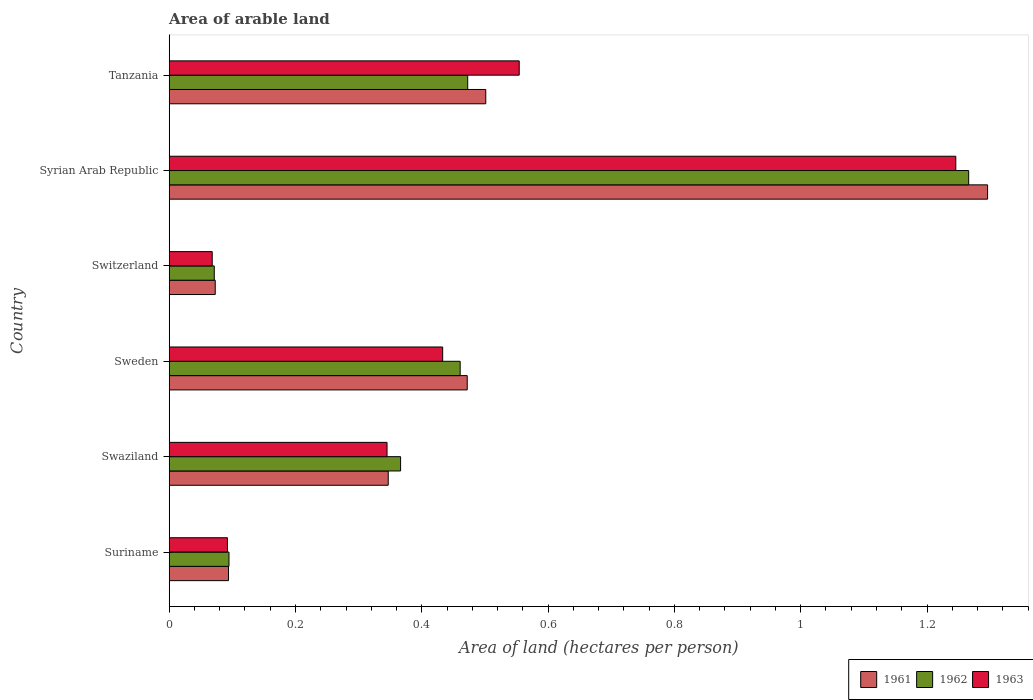How many different coloured bars are there?
Your response must be concise. 3. Are the number of bars per tick equal to the number of legend labels?
Ensure brevity in your answer.  Yes. How many bars are there on the 1st tick from the top?
Give a very brief answer. 3. What is the label of the 1st group of bars from the top?
Offer a terse response. Tanzania. In how many cases, is the number of bars for a given country not equal to the number of legend labels?
Keep it short and to the point. 0. What is the total arable land in 1961 in Syrian Arab Republic?
Offer a terse response. 1.3. Across all countries, what is the maximum total arable land in 1962?
Offer a very short reply. 1.27. Across all countries, what is the minimum total arable land in 1961?
Offer a very short reply. 0.07. In which country was the total arable land in 1962 maximum?
Your answer should be compact. Syrian Arab Republic. In which country was the total arable land in 1963 minimum?
Provide a short and direct response. Switzerland. What is the total total arable land in 1962 in the graph?
Offer a terse response. 2.73. What is the difference between the total arable land in 1962 in Swaziland and that in Tanzania?
Your answer should be compact. -0.11. What is the difference between the total arable land in 1961 in Syrian Arab Republic and the total arable land in 1963 in Tanzania?
Provide a succinct answer. 0.74. What is the average total arable land in 1963 per country?
Your response must be concise. 0.46. What is the difference between the total arable land in 1962 and total arable land in 1961 in Sweden?
Offer a terse response. -0.01. What is the ratio of the total arable land in 1962 in Swaziland to that in Switzerland?
Provide a short and direct response. 5.14. What is the difference between the highest and the second highest total arable land in 1963?
Offer a very short reply. 0.69. What is the difference between the highest and the lowest total arable land in 1962?
Offer a terse response. 1.19. In how many countries, is the total arable land in 1961 greater than the average total arable land in 1961 taken over all countries?
Your response must be concise. 3. What does the 3rd bar from the top in Swaziland represents?
Your response must be concise. 1961. Is it the case that in every country, the sum of the total arable land in 1961 and total arable land in 1962 is greater than the total arable land in 1963?
Keep it short and to the point. Yes. How many bars are there?
Make the answer very short. 18. Are all the bars in the graph horizontal?
Provide a short and direct response. Yes. How many countries are there in the graph?
Ensure brevity in your answer.  6. Are the values on the major ticks of X-axis written in scientific E-notation?
Your answer should be very brief. No. Does the graph contain any zero values?
Your response must be concise. No. How many legend labels are there?
Give a very brief answer. 3. How are the legend labels stacked?
Provide a succinct answer. Horizontal. What is the title of the graph?
Ensure brevity in your answer.  Area of arable land. Does "2003" appear as one of the legend labels in the graph?
Make the answer very short. No. What is the label or title of the X-axis?
Your answer should be very brief. Area of land (hectares per person). What is the Area of land (hectares per person) in 1961 in Suriname?
Make the answer very short. 0.09. What is the Area of land (hectares per person) of 1962 in Suriname?
Your response must be concise. 0.09. What is the Area of land (hectares per person) in 1963 in Suriname?
Provide a short and direct response. 0.09. What is the Area of land (hectares per person) of 1961 in Swaziland?
Provide a succinct answer. 0.35. What is the Area of land (hectares per person) in 1962 in Swaziland?
Your response must be concise. 0.37. What is the Area of land (hectares per person) in 1963 in Swaziland?
Your answer should be very brief. 0.34. What is the Area of land (hectares per person) in 1961 in Sweden?
Provide a short and direct response. 0.47. What is the Area of land (hectares per person) in 1962 in Sweden?
Offer a terse response. 0.46. What is the Area of land (hectares per person) in 1963 in Sweden?
Ensure brevity in your answer.  0.43. What is the Area of land (hectares per person) of 1961 in Switzerland?
Make the answer very short. 0.07. What is the Area of land (hectares per person) of 1962 in Switzerland?
Your answer should be compact. 0.07. What is the Area of land (hectares per person) in 1963 in Switzerland?
Your response must be concise. 0.07. What is the Area of land (hectares per person) of 1961 in Syrian Arab Republic?
Your response must be concise. 1.3. What is the Area of land (hectares per person) of 1962 in Syrian Arab Republic?
Provide a succinct answer. 1.27. What is the Area of land (hectares per person) in 1963 in Syrian Arab Republic?
Offer a very short reply. 1.25. What is the Area of land (hectares per person) in 1961 in Tanzania?
Keep it short and to the point. 0.5. What is the Area of land (hectares per person) of 1962 in Tanzania?
Your answer should be compact. 0.47. What is the Area of land (hectares per person) of 1963 in Tanzania?
Offer a very short reply. 0.55. Across all countries, what is the maximum Area of land (hectares per person) in 1961?
Provide a short and direct response. 1.3. Across all countries, what is the maximum Area of land (hectares per person) of 1962?
Ensure brevity in your answer.  1.27. Across all countries, what is the maximum Area of land (hectares per person) in 1963?
Give a very brief answer. 1.25. Across all countries, what is the minimum Area of land (hectares per person) of 1961?
Provide a succinct answer. 0.07. Across all countries, what is the minimum Area of land (hectares per person) of 1962?
Provide a succinct answer. 0.07. Across all countries, what is the minimum Area of land (hectares per person) in 1963?
Make the answer very short. 0.07. What is the total Area of land (hectares per person) of 1961 in the graph?
Make the answer very short. 2.78. What is the total Area of land (hectares per person) of 1962 in the graph?
Make the answer very short. 2.73. What is the total Area of land (hectares per person) in 1963 in the graph?
Offer a very short reply. 2.74. What is the difference between the Area of land (hectares per person) of 1961 in Suriname and that in Swaziland?
Your answer should be compact. -0.25. What is the difference between the Area of land (hectares per person) of 1962 in Suriname and that in Swaziland?
Offer a terse response. -0.27. What is the difference between the Area of land (hectares per person) in 1963 in Suriname and that in Swaziland?
Make the answer very short. -0.25. What is the difference between the Area of land (hectares per person) in 1961 in Suriname and that in Sweden?
Your response must be concise. -0.38. What is the difference between the Area of land (hectares per person) in 1962 in Suriname and that in Sweden?
Your response must be concise. -0.37. What is the difference between the Area of land (hectares per person) in 1963 in Suriname and that in Sweden?
Offer a very short reply. -0.34. What is the difference between the Area of land (hectares per person) of 1961 in Suriname and that in Switzerland?
Provide a succinct answer. 0.02. What is the difference between the Area of land (hectares per person) of 1962 in Suriname and that in Switzerland?
Keep it short and to the point. 0.02. What is the difference between the Area of land (hectares per person) of 1963 in Suriname and that in Switzerland?
Provide a succinct answer. 0.02. What is the difference between the Area of land (hectares per person) of 1961 in Suriname and that in Syrian Arab Republic?
Give a very brief answer. -1.2. What is the difference between the Area of land (hectares per person) of 1962 in Suriname and that in Syrian Arab Republic?
Offer a very short reply. -1.17. What is the difference between the Area of land (hectares per person) of 1963 in Suriname and that in Syrian Arab Republic?
Your answer should be very brief. -1.15. What is the difference between the Area of land (hectares per person) of 1961 in Suriname and that in Tanzania?
Keep it short and to the point. -0.41. What is the difference between the Area of land (hectares per person) in 1962 in Suriname and that in Tanzania?
Your response must be concise. -0.38. What is the difference between the Area of land (hectares per person) of 1963 in Suriname and that in Tanzania?
Keep it short and to the point. -0.46. What is the difference between the Area of land (hectares per person) of 1961 in Swaziland and that in Sweden?
Your answer should be very brief. -0.13. What is the difference between the Area of land (hectares per person) in 1962 in Swaziland and that in Sweden?
Your answer should be very brief. -0.09. What is the difference between the Area of land (hectares per person) in 1963 in Swaziland and that in Sweden?
Your answer should be compact. -0.09. What is the difference between the Area of land (hectares per person) in 1961 in Swaziland and that in Switzerland?
Provide a short and direct response. 0.27. What is the difference between the Area of land (hectares per person) in 1962 in Swaziland and that in Switzerland?
Your response must be concise. 0.3. What is the difference between the Area of land (hectares per person) of 1963 in Swaziland and that in Switzerland?
Your response must be concise. 0.28. What is the difference between the Area of land (hectares per person) in 1961 in Swaziland and that in Syrian Arab Republic?
Make the answer very short. -0.95. What is the difference between the Area of land (hectares per person) in 1962 in Swaziland and that in Syrian Arab Republic?
Your answer should be very brief. -0.9. What is the difference between the Area of land (hectares per person) of 1963 in Swaziland and that in Syrian Arab Republic?
Your response must be concise. -0.9. What is the difference between the Area of land (hectares per person) of 1961 in Swaziland and that in Tanzania?
Keep it short and to the point. -0.15. What is the difference between the Area of land (hectares per person) in 1962 in Swaziland and that in Tanzania?
Your answer should be very brief. -0.11. What is the difference between the Area of land (hectares per person) in 1963 in Swaziland and that in Tanzania?
Make the answer very short. -0.21. What is the difference between the Area of land (hectares per person) of 1961 in Sweden and that in Switzerland?
Offer a terse response. 0.4. What is the difference between the Area of land (hectares per person) of 1962 in Sweden and that in Switzerland?
Your response must be concise. 0.39. What is the difference between the Area of land (hectares per person) in 1963 in Sweden and that in Switzerland?
Your answer should be very brief. 0.36. What is the difference between the Area of land (hectares per person) in 1961 in Sweden and that in Syrian Arab Republic?
Make the answer very short. -0.82. What is the difference between the Area of land (hectares per person) in 1962 in Sweden and that in Syrian Arab Republic?
Provide a short and direct response. -0.81. What is the difference between the Area of land (hectares per person) of 1963 in Sweden and that in Syrian Arab Republic?
Offer a terse response. -0.81. What is the difference between the Area of land (hectares per person) in 1961 in Sweden and that in Tanzania?
Make the answer very short. -0.03. What is the difference between the Area of land (hectares per person) in 1962 in Sweden and that in Tanzania?
Your answer should be very brief. -0.01. What is the difference between the Area of land (hectares per person) of 1963 in Sweden and that in Tanzania?
Your answer should be compact. -0.12. What is the difference between the Area of land (hectares per person) of 1961 in Switzerland and that in Syrian Arab Republic?
Ensure brevity in your answer.  -1.22. What is the difference between the Area of land (hectares per person) in 1962 in Switzerland and that in Syrian Arab Republic?
Your response must be concise. -1.19. What is the difference between the Area of land (hectares per person) in 1963 in Switzerland and that in Syrian Arab Republic?
Provide a succinct answer. -1.18. What is the difference between the Area of land (hectares per person) in 1961 in Switzerland and that in Tanzania?
Offer a terse response. -0.43. What is the difference between the Area of land (hectares per person) in 1962 in Switzerland and that in Tanzania?
Provide a short and direct response. -0.4. What is the difference between the Area of land (hectares per person) of 1963 in Switzerland and that in Tanzania?
Offer a terse response. -0.49. What is the difference between the Area of land (hectares per person) of 1961 in Syrian Arab Republic and that in Tanzania?
Your answer should be very brief. 0.79. What is the difference between the Area of land (hectares per person) in 1962 in Syrian Arab Republic and that in Tanzania?
Offer a terse response. 0.79. What is the difference between the Area of land (hectares per person) in 1963 in Syrian Arab Republic and that in Tanzania?
Offer a very short reply. 0.69. What is the difference between the Area of land (hectares per person) of 1961 in Suriname and the Area of land (hectares per person) of 1962 in Swaziland?
Provide a short and direct response. -0.27. What is the difference between the Area of land (hectares per person) in 1961 in Suriname and the Area of land (hectares per person) in 1963 in Swaziland?
Your answer should be very brief. -0.25. What is the difference between the Area of land (hectares per person) in 1962 in Suriname and the Area of land (hectares per person) in 1963 in Swaziland?
Make the answer very short. -0.25. What is the difference between the Area of land (hectares per person) of 1961 in Suriname and the Area of land (hectares per person) of 1962 in Sweden?
Offer a terse response. -0.37. What is the difference between the Area of land (hectares per person) of 1961 in Suriname and the Area of land (hectares per person) of 1963 in Sweden?
Make the answer very short. -0.34. What is the difference between the Area of land (hectares per person) of 1962 in Suriname and the Area of land (hectares per person) of 1963 in Sweden?
Ensure brevity in your answer.  -0.34. What is the difference between the Area of land (hectares per person) in 1961 in Suriname and the Area of land (hectares per person) in 1962 in Switzerland?
Provide a succinct answer. 0.02. What is the difference between the Area of land (hectares per person) of 1961 in Suriname and the Area of land (hectares per person) of 1963 in Switzerland?
Your response must be concise. 0.03. What is the difference between the Area of land (hectares per person) in 1962 in Suriname and the Area of land (hectares per person) in 1963 in Switzerland?
Give a very brief answer. 0.03. What is the difference between the Area of land (hectares per person) in 1961 in Suriname and the Area of land (hectares per person) in 1962 in Syrian Arab Republic?
Provide a succinct answer. -1.17. What is the difference between the Area of land (hectares per person) of 1961 in Suriname and the Area of land (hectares per person) of 1963 in Syrian Arab Republic?
Offer a terse response. -1.15. What is the difference between the Area of land (hectares per person) of 1962 in Suriname and the Area of land (hectares per person) of 1963 in Syrian Arab Republic?
Your response must be concise. -1.15. What is the difference between the Area of land (hectares per person) in 1961 in Suriname and the Area of land (hectares per person) in 1962 in Tanzania?
Offer a very short reply. -0.38. What is the difference between the Area of land (hectares per person) of 1961 in Suriname and the Area of land (hectares per person) of 1963 in Tanzania?
Your response must be concise. -0.46. What is the difference between the Area of land (hectares per person) of 1962 in Suriname and the Area of land (hectares per person) of 1963 in Tanzania?
Offer a terse response. -0.46. What is the difference between the Area of land (hectares per person) in 1961 in Swaziland and the Area of land (hectares per person) in 1962 in Sweden?
Give a very brief answer. -0.11. What is the difference between the Area of land (hectares per person) in 1961 in Swaziland and the Area of land (hectares per person) in 1963 in Sweden?
Your response must be concise. -0.09. What is the difference between the Area of land (hectares per person) in 1962 in Swaziland and the Area of land (hectares per person) in 1963 in Sweden?
Provide a short and direct response. -0.07. What is the difference between the Area of land (hectares per person) in 1961 in Swaziland and the Area of land (hectares per person) in 1962 in Switzerland?
Your answer should be compact. 0.28. What is the difference between the Area of land (hectares per person) of 1961 in Swaziland and the Area of land (hectares per person) of 1963 in Switzerland?
Offer a terse response. 0.28. What is the difference between the Area of land (hectares per person) of 1962 in Swaziland and the Area of land (hectares per person) of 1963 in Switzerland?
Provide a short and direct response. 0.3. What is the difference between the Area of land (hectares per person) of 1961 in Swaziland and the Area of land (hectares per person) of 1962 in Syrian Arab Republic?
Offer a very short reply. -0.92. What is the difference between the Area of land (hectares per person) of 1961 in Swaziland and the Area of land (hectares per person) of 1963 in Syrian Arab Republic?
Provide a succinct answer. -0.9. What is the difference between the Area of land (hectares per person) in 1962 in Swaziland and the Area of land (hectares per person) in 1963 in Syrian Arab Republic?
Offer a very short reply. -0.88. What is the difference between the Area of land (hectares per person) of 1961 in Swaziland and the Area of land (hectares per person) of 1962 in Tanzania?
Give a very brief answer. -0.13. What is the difference between the Area of land (hectares per person) of 1961 in Swaziland and the Area of land (hectares per person) of 1963 in Tanzania?
Offer a terse response. -0.21. What is the difference between the Area of land (hectares per person) of 1962 in Swaziland and the Area of land (hectares per person) of 1963 in Tanzania?
Provide a succinct answer. -0.19. What is the difference between the Area of land (hectares per person) of 1961 in Sweden and the Area of land (hectares per person) of 1962 in Switzerland?
Your answer should be very brief. 0.4. What is the difference between the Area of land (hectares per person) of 1961 in Sweden and the Area of land (hectares per person) of 1963 in Switzerland?
Keep it short and to the point. 0.4. What is the difference between the Area of land (hectares per person) of 1962 in Sweden and the Area of land (hectares per person) of 1963 in Switzerland?
Provide a succinct answer. 0.39. What is the difference between the Area of land (hectares per person) in 1961 in Sweden and the Area of land (hectares per person) in 1962 in Syrian Arab Republic?
Offer a terse response. -0.79. What is the difference between the Area of land (hectares per person) of 1961 in Sweden and the Area of land (hectares per person) of 1963 in Syrian Arab Republic?
Your response must be concise. -0.77. What is the difference between the Area of land (hectares per person) in 1962 in Sweden and the Area of land (hectares per person) in 1963 in Syrian Arab Republic?
Ensure brevity in your answer.  -0.78. What is the difference between the Area of land (hectares per person) in 1961 in Sweden and the Area of land (hectares per person) in 1962 in Tanzania?
Provide a short and direct response. -0. What is the difference between the Area of land (hectares per person) in 1961 in Sweden and the Area of land (hectares per person) in 1963 in Tanzania?
Your response must be concise. -0.08. What is the difference between the Area of land (hectares per person) of 1962 in Sweden and the Area of land (hectares per person) of 1963 in Tanzania?
Offer a very short reply. -0.09. What is the difference between the Area of land (hectares per person) in 1961 in Switzerland and the Area of land (hectares per person) in 1962 in Syrian Arab Republic?
Offer a terse response. -1.19. What is the difference between the Area of land (hectares per person) in 1961 in Switzerland and the Area of land (hectares per person) in 1963 in Syrian Arab Republic?
Your answer should be compact. -1.17. What is the difference between the Area of land (hectares per person) in 1962 in Switzerland and the Area of land (hectares per person) in 1963 in Syrian Arab Republic?
Provide a short and direct response. -1.17. What is the difference between the Area of land (hectares per person) of 1961 in Switzerland and the Area of land (hectares per person) of 1962 in Tanzania?
Your response must be concise. -0.4. What is the difference between the Area of land (hectares per person) in 1961 in Switzerland and the Area of land (hectares per person) in 1963 in Tanzania?
Offer a terse response. -0.48. What is the difference between the Area of land (hectares per person) in 1962 in Switzerland and the Area of land (hectares per person) in 1963 in Tanzania?
Provide a succinct answer. -0.48. What is the difference between the Area of land (hectares per person) of 1961 in Syrian Arab Republic and the Area of land (hectares per person) of 1962 in Tanzania?
Your answer should be compact. 0.82. What is the difference between the Area of land (hectares per person) of 1961 in Syrian Arab Republic and the Area of land (hectares per person) of 1963 in Tanzania?
Ensure brevity in your answer.  0.74. What is the difference between the Area of land (hectares per person) of 1962 in Syrian Arab Republic and the Area of land (hectares per person) of 1963 in Tanzania?
Provide a succinct answer. 0.71. What is the average Area of land (hectares per person) of 1961 per country?
Make the answer very short. 0.46. What is the average Area of land (hectares per person) in 1962 per country?
Make the answer very short. 0.46. What is the average Area of land (hectares per person) of 1963 per country?
Keep it short and to the point. 0.46. What is the difference between the Area of land (hectares per person) of 1961 and Area of land (hectares per person) of 1962 in Suriname?
Offer a terse response. -0. What is the difference between the Area of land (hectares per person) in 1961 and Area of land (hectares per person) in 1963 in Suriname?
Your answer should be compact. 0. What is the difference between the Area of land (hectares per person) of 1962 and Area of land (hectares per person) of 1963 in Suriname?
Make the answer very short. 0. What is the difference between the Area of land (hectares per person) of 1961 and Area of land (hectares per person) of 1962 in Swaziland?
Give a very brief answer. -0.02. What is the difference between the Area of land (hectares per person) of 1961 and Area of land (hectares per person) of 1963 in Swaziland?
Provide a succinct answer. 0. What is the difference between the Area of land (hectares per person) in 1962 and Area of land (hectares per person) in 1963 in Swaziland?
Provide a succinct answer. 0.02. What is the difference between the Area of land (hectares per person) in 1961 and Area of land (hectares per person) in 1962 in Sweden?
Ensure brevity in your answer.  0.01. What is the difference between the Area of land (hectares per person) of 1961 and Area of land (hectares per person) of 1963 in Sweden?
Offer a terse response. 0.04. What is the difference between the Area of land (hectares per person) of 1962 and Area of land (hectares per person) of 1963 in Sweden?
Your response must be concise. 0.03. What is the difference between the Area of land (hectares per person) in 1961 and Area of land (hectares per person) in 1962 in Switzerland?
Offer a terse response. 0. What is the difference between the Area of land (hectares per person) in 1961 and Area of land (hectares per person) in 1963 in Switzerland?
Keep it short and to the point. 0. What is the difference between the Area of land (hectares per person) of 1962 and Area of land (hectares per person) of 1963 in Switzerland?
Offer a very short reply. 0. What is the difference between the Area of land (hectares per person) in 1961 and Area of land (hectares per person) in 1962 in Syrian Arab Republic?
Your answer should be very brief. 0.03. What is the difference between the Area of land (hectares per person) of 1961 and Area of land (hectares per person) of 1963 in Syrian Arab Republic?
Ensure brevity in your answer.  0.05. What is the difference between the Area of land (hectares per person) in 1962 and Area of land (hectares per person) in 1963 in Syrian Arab Republic?
Make the answer very short. 0.02. What is the difference between the Area of land (hectares per person) in 1961 and Area of land (hectares per person) in 1962 in Tanzania?
Keep it short and to the point. 0.03. What is the difference between the Area of land (hectares per person) in 1961 and Area of land (hectares per person) in 1963 in Tanzania?
Ensure brevity in your answer.  -0.05. What is the difference between the Area of land (hectares per person) of 1962 and Area of land (hectares per person) of 1963 in Tanzania?
Provide a succinct answer. -0.08. What is the ratio of the Area of land (hectares per person) in 1961 in Suriname to that in Swaziland?
Provide a short and direct response. 0.27. What is the ratio of the Area of land (hectares per person) in 1962 in Suriname to that in Swaziland?
Give a very brief answer. 0.26. What is the ratio of the Area of land (hectares per person) of 1963 in Suriname to that in Swaziland?
Make the answer very short. 0.27. What is the ratio of the Area of land (hectares per person) in 1961 in Suriname to that in Sweden?
Your answer should be compact. 0.2. What is the ratio of the Area of land (hectares per person) of 1962 in Suriname to that in Sweden?
Ensure brevity in your answer.  0.21. What is the ratio of the Area of land (hectares per person) in 1963 in Suriname to that in Sweden?
Keep it short and to the point. 0.21. What is the ratio of the Area of land (hectares per person) in 1961 in Suriname to that in Switzerland?
Offer a terse response. 1.29. What is the ratio of the Area of land (hectares per person) in 1962 in Suriname to that in Switzerland?
Offer a terse response. 1.33. What is the ratio of the Area of land (hectares per person) of 1963 in Suriname to that in Switzerland?
Ensure brevity in your answer.  1.35. What is the ratio of the Area of land (hectares per person) in 1961 in Suriname to that in Syrian Arab Republic?
Offer a very short reply. 0.07. What is the ratio of the Area of land (hectares per person) in 1962 in Suriname to that in Syrian Arab Republic?
Provide a succinct answer. 0.07. What is the ratio of the Area of land (hectares per person) in 1963 in Suriname to that in Syrian Arab Republic?
Ensure brevity in your answer.  0.07. What is the ratio of the Area of land (hectares per person) in 1961 in Suriname to that in Tanzania?
Ensure brevity in your answer.  0.19. What is the ratio of the Area of land (hectares per person) in 1962 in Suriname to that in Tanzania?
Offer a very short reply. 0.2. What is the ratio of the Area of land (hectares per person) of 1963 in Suriname to that in Tanzania?
Your response must be concise. 0.17. What is the ratio of the Area of land (hectares per person) in 1961 in Swaziland to that in Sweden?
Provide a succinct answer. 0.73. What is the ratio of the Area of land (hectares per person) of 1962 in Swaziland to that in Sweden?
Ensure brevity in your answer.  0.8. What is the ratio of the Area of land (hectares per person) in 1963 in Swaziland to that in Sweden?
Provide a succinct answer. 0.8. What is the ratio of the Area of land (hectares per person) of 1961 in Swaziland to that in Switzerland?
Offer a terse response. 4.76. What is the ratio of the Area of land (hectares per person) of 1962 in Swaziland to that in Switzerland?
Offer a terse response. 5.14. What is the ratio of the Area of land (hectares per person) in 1963 in Swaziland to that in Switzerland?
Your answer should be compact. 5.06. What is the ratio of the Area of land (hectares per person) in 1961 in Swaziland to that in Syrian Arab Republic?
Provide a short and direct response. 0.27. What is the ratio of the Area of land (hectares per person) in 1962 in Swaziland to that in Syrian Arab Republic?
Your answer should be compact. 0.29. What is the ratio of the Area of land (hectares per person) in 1963 in Swaziland to that in Syrian Arab Republic?
Your answer should be compact. 0.28. What is the ratio of the Area of land (hectares per person) in 1961 in Swaziland to that in Tanzania?
Ensure brevity in your answer.  0.69. What is the ratio of the Area of land (hectares per person) of 1962 in Swaziland to that in Tanzania?
Provide a succinct answer. 0.78. What is the ratio of the Area of land (hectares per person) in 1963 in Swaziland to that in Tanzania?
Ensure brevity in your answer.  0.62. What is the ratio of the Area of land (hectares per person) of 1961 in Sweden to that in Switzerland?
Ensure brevity in your answer.  6.47. What is the ratio of the Area of land (hectares per person) in 1962 in Sweden to that in Switzerland?
Your answer should be compact. 6.46. What is the ratio of the Area of land (hectares per person) of 1963 in Sweden to that in Switzerland?
Offer a terse response. 6.36. What is the ratio of the Area of land (hectares per person) in 1961 in Sweden to that in Syrian Arab Republic?
Your answer should be very brief. 0.36. What is the ratio of the Area of land (hectares per person) in 1962 in Sweden to that in Syrian Arab Republic?
Keep it short and to the point. 0.36. What is the ratio of the Area of land (hectares per person) of 1963 in Sweden to that in Syrian Arab Republic?
Offer a very short reply. 0.35. What is the ratio of the Area of land (hectares per person) in 1961 in Sweden to that in Tanzania?
Keep it short and to the point. 0.94. What is the ratio of the Area of land (hectares per person) of 1962 in Sweden to that in Tanzania?
Provide a succinct answer. 0.97. What is the ratio of the Area of land (hectares per person) in 1963 in Sweden to that in Tanzania?
Keep it short and to the point. 0.78. What is the ratio of the Area of land (hectares per person) of 1961 in Switzerland to that in Syrian Arab Republic?
Provide a short and direct response. 0.06. What is the ratio of the Area of land (hectares per person) of 1962 in Switzerland to that in Syrian Arab Republic?
Your answer should be compact. 0.06. What is the ratio of the Area of land (hectares per person) of 1963 in Switzerland to that in Syrian Arab Republic?
Your answer should be compact. 0.05. What is the ratio of the Area of land (hectares per person) in 1961 in Switzerland to that in Tanzania?
Offer a very short reply. 0.15. What is the ratio of the Area of land (hectares per person) in 1962 in Switzerland to that in Tanzania?
Keep it short and to the point. 0.15. What is the ratio of the Area of land (hectares per person) of 1963 in Switzerland to that in Tanzania?
Make the answer very short. 0.12. What is the ratio of the Area of land (hectares per person) in 1961 in Syrian Arab Republic to that in Tanzania?
Keep it short and to the point. 2.59. What is the ratio of the Area of land (hectares per person) in 1962 in Syrian Arab Republic to that in Tanzania?
Make the answer very short. 2.68. What is the ratio of the Area of land (hectares per person) of 1963 in Syrian Arab Republic to that in Tanzania?
Offer a terse response. 2.25. What is the difference between the highest and the second highest Area of land (hectares per person) in 1961?
Your answer should be compact. 0.79. What is the difference between the highest and the second highest Area of land (hectares per person) of 1962?
Keep it short and to the point. 0.79. What is the difference between the highest and the second highest Area of land (hectares per person) of 1963?
Offer a very short reply. 0.69. What is the difference between the highest and the lowest Area of land (hectares per person) of 1961?
Provide a short and direct response. 1.22. What is the difference between the highest and the lowest Area of land (hectares per person) of 1962?
Offer a terse response. 1.19. What is the difference between the highest and the lowest Area of land (hectares per person) in 1963?
Keep it short and to the point. 1.18. 